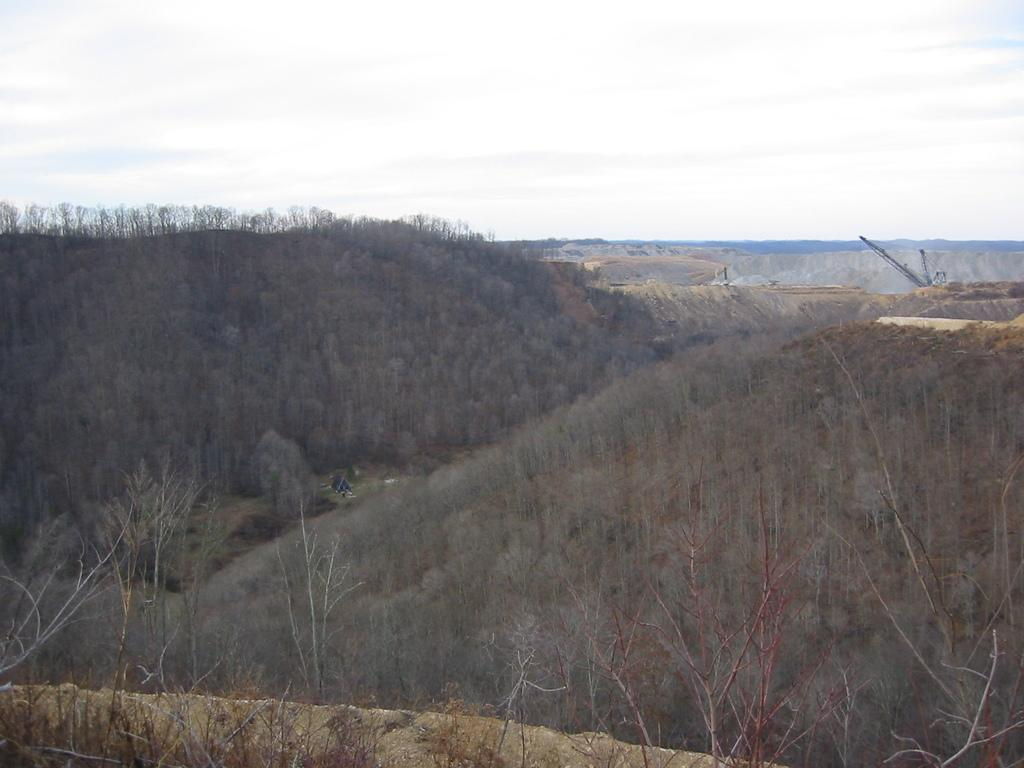What type of vegetation can be seen in the image? There are plants and trees in the image. What structure is visible in the image? There is a crane in the image. What can be seen in the background of the image? The sky is visible in the background of the image. What type of property is being divided in the image? There is no indication of any property or division in the image; it features plants, trees, and a crane. 